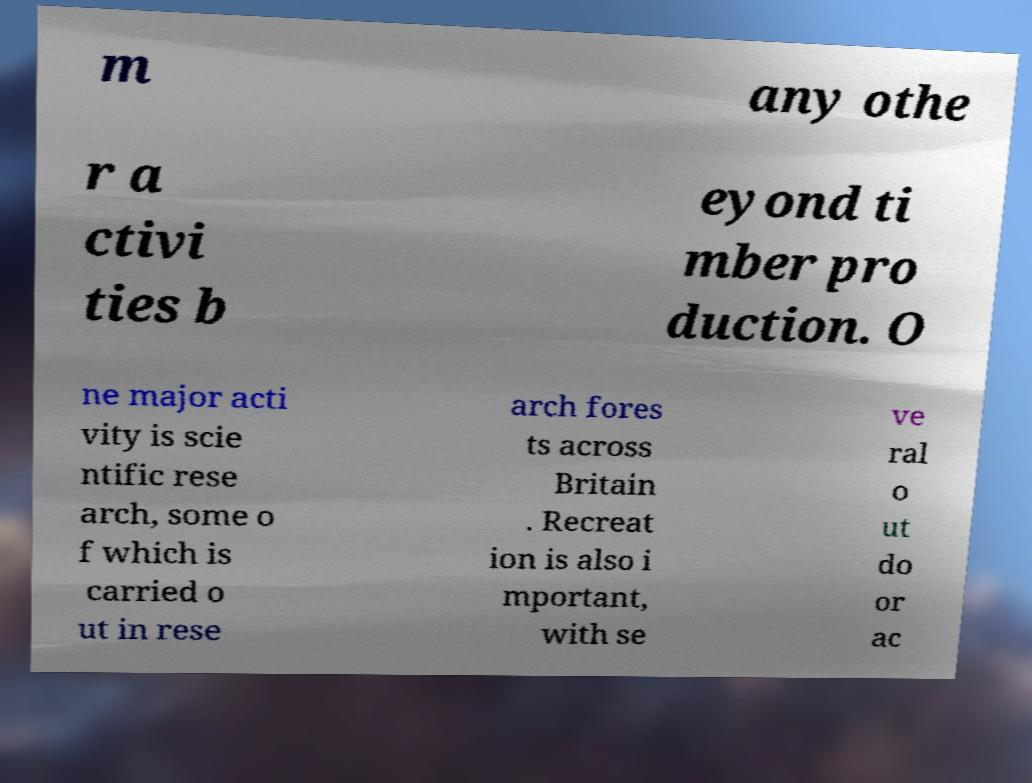Could you extract and type out the text from this image? m any othe r a ctivi ties b eyond ti mber pro duction. O ne major acti vity is scie ntific rese arch, some o f which is carried o ut in rese arch fores ts across Britain . Recreat ion is also i mportant, with se ve ral o ut do or ac 